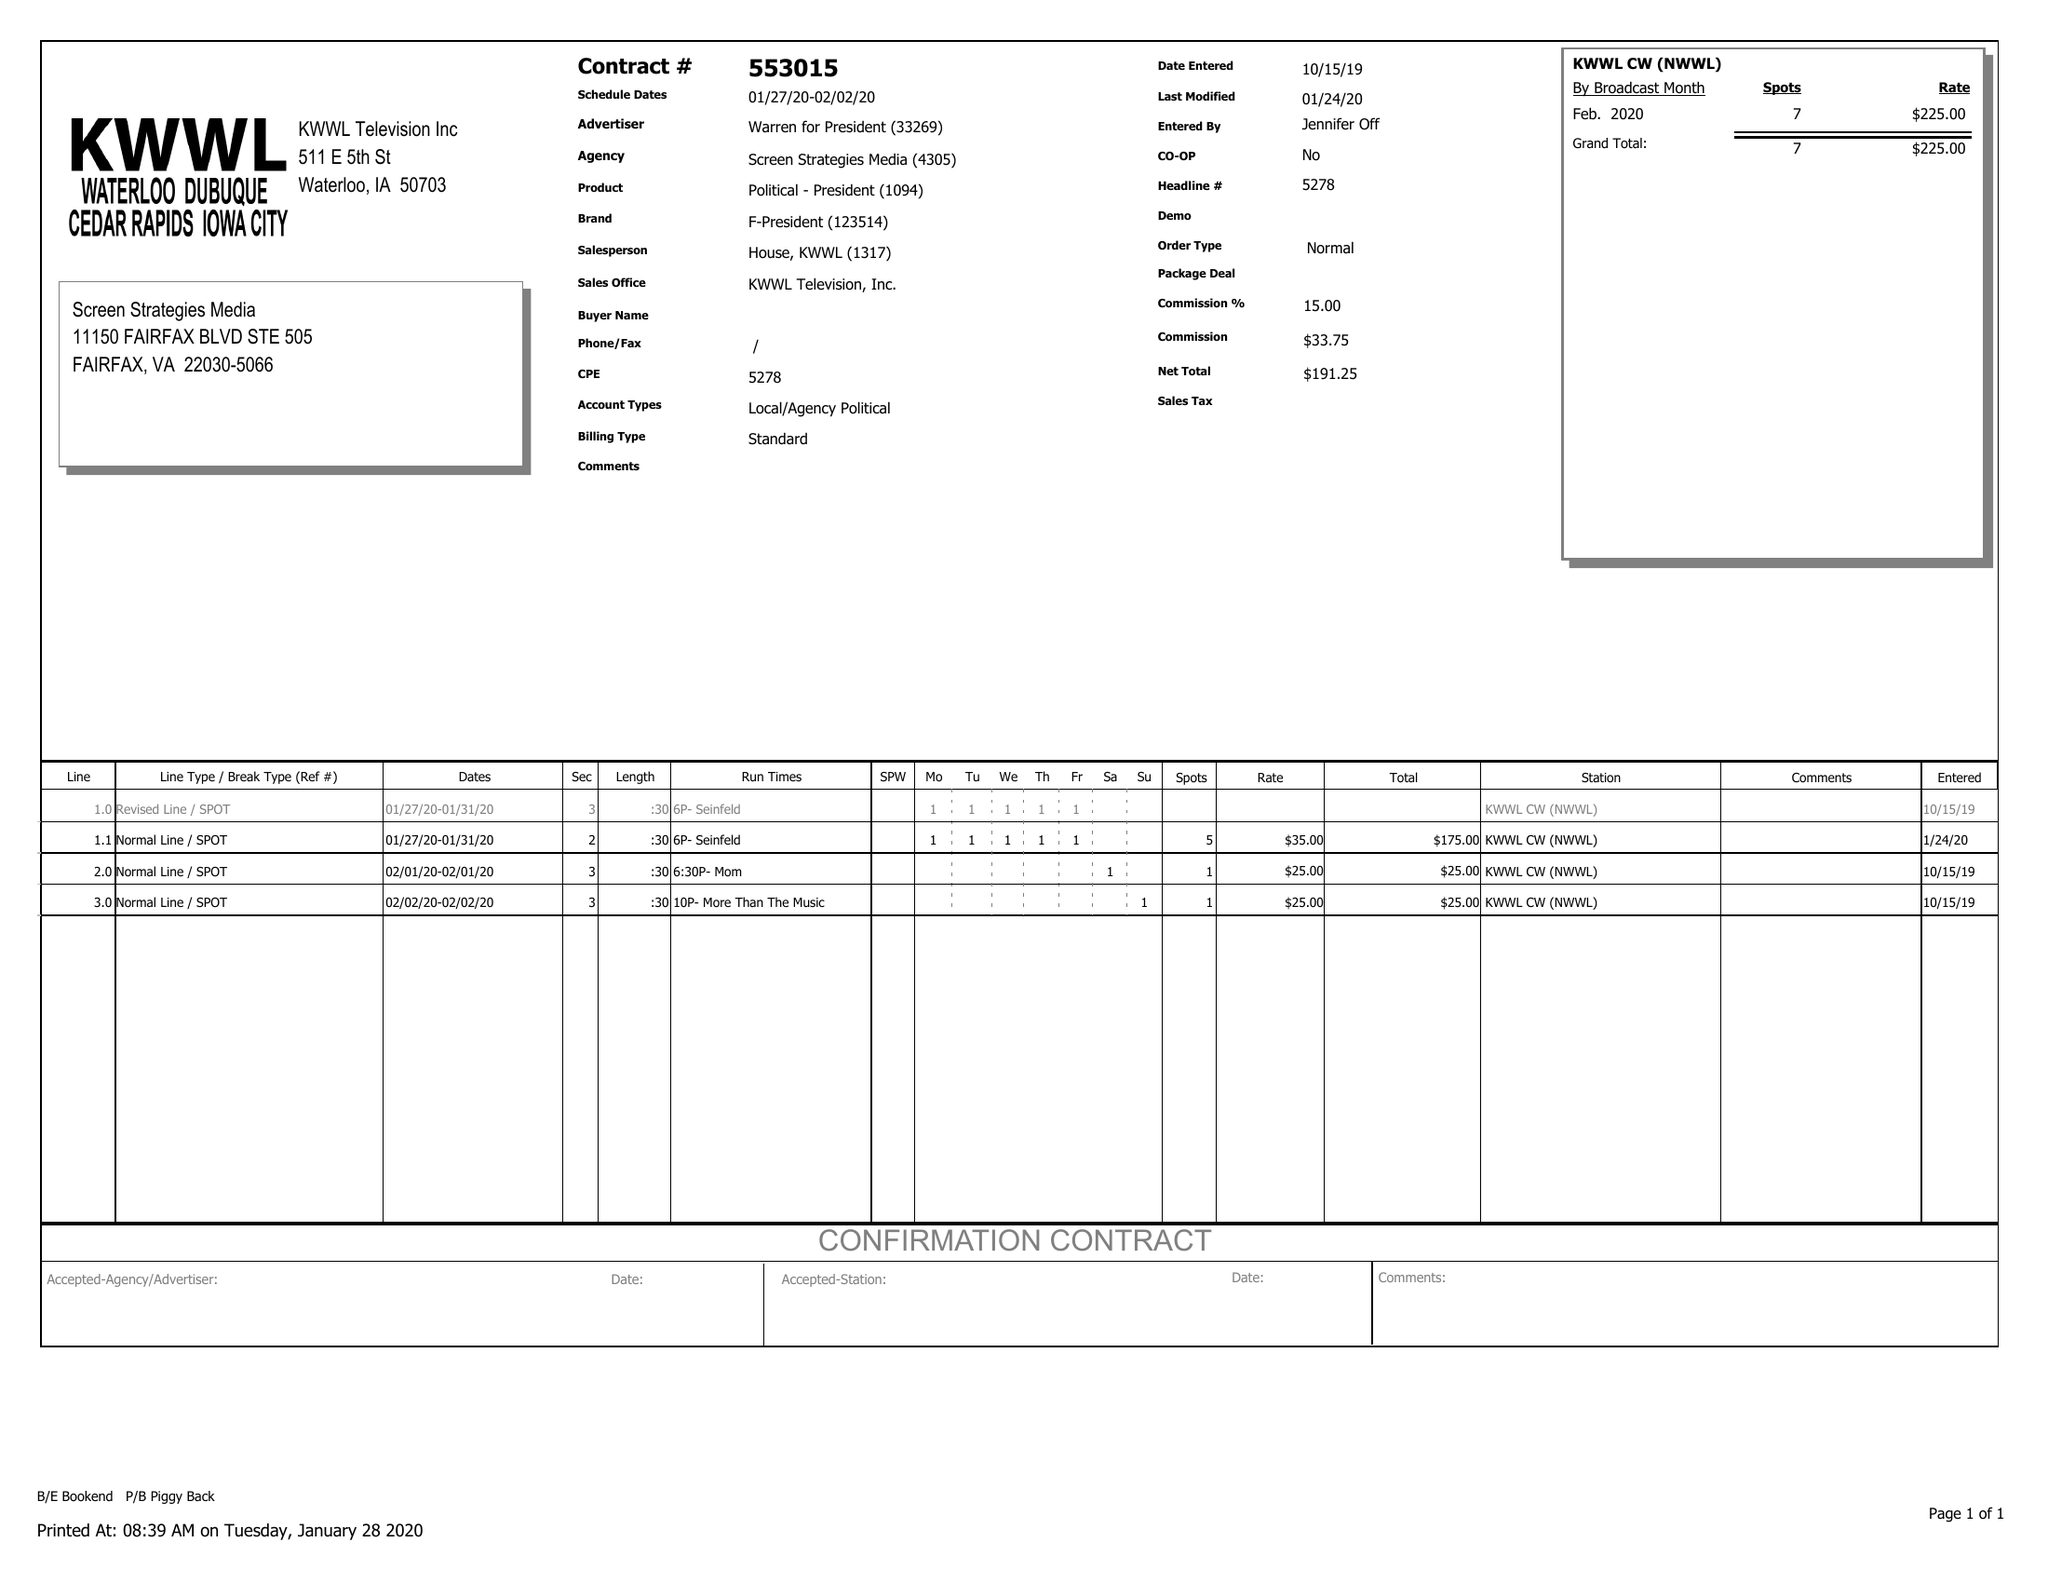What is the value for the gross_amount?
Answer the question using a single word or phrase. 225.00 